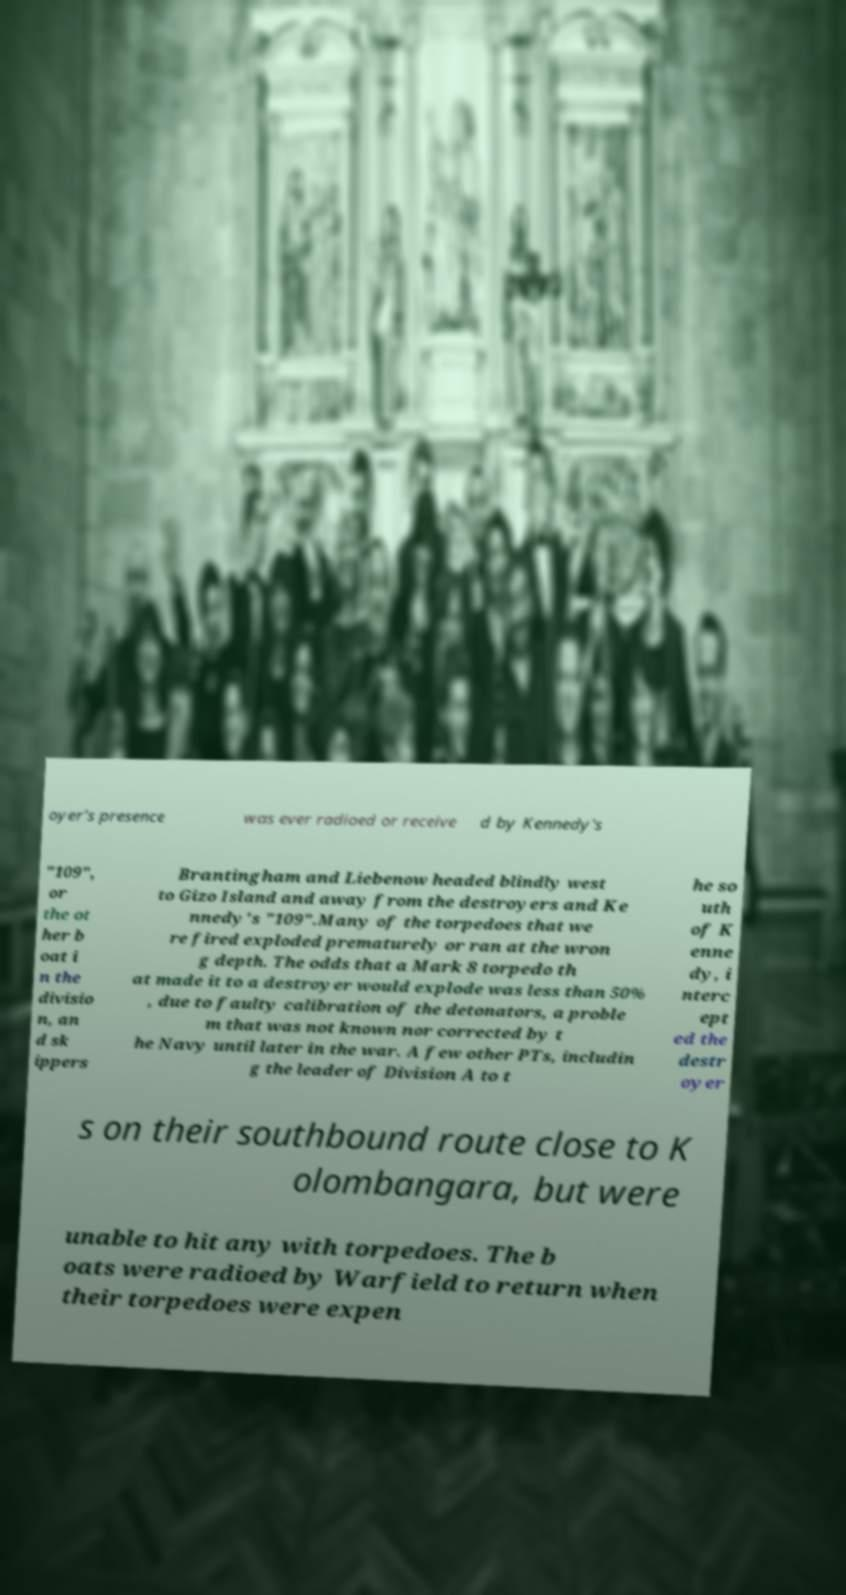Please identify and transcribe the text found in this image. oyer's presence was ever radioed or receive d by Kennedy's "109", or the ot her b oat i n the divisio n, an d sk ippers Brantingham and Liebenow headed blindly west to Gizo Island and away from the destroyers and Ke nnedy's "109".Many of the torpedoes that we re fired exploded prematurely or ran at the wron g depth. The odds that a Mark 8 torpedo th at made it to a destroyer would explode was less than 50% , due to faulty calibration of the detonators, a proble m that was not known nor corrected by t he Navy until later in the war. A few other PTs, includin g the leader of Division A to t he so uth of K enne dy, i nterc ept ed the destr oyer s on their southbound route close to K olombangara, but were unable to hit any with torpedoes. The b oats were radioed by Warfield to return when their torpedoes were expen 